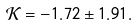Convert formula to latex. <formula><loc_0><loc_0><loc_500><loc_500>\mathcal { K } = - 1 . 7 2 \pm 1 . 9 1 .</formula> 